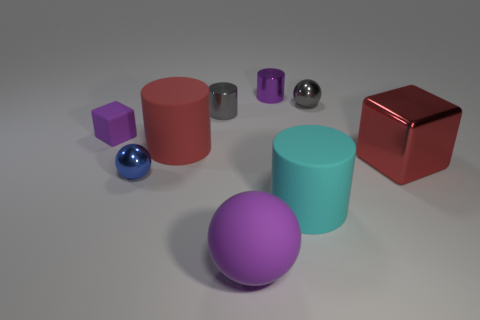Subtract all yellow balls. Subtract all yellow blocks. How many balls are left? 3 Subtract all cylinders. How many objects are left? 5 Subtract all tiny red cylinders. Subtract all cyan cylinders. How many objects are left? 8 Add 8 gray objects. How many gray objects are left? 10 Add 7 large brown cylinders. How many large brown cylinders exist? 7 Subtract 1 purple cylinders. How many objects are left? 8 